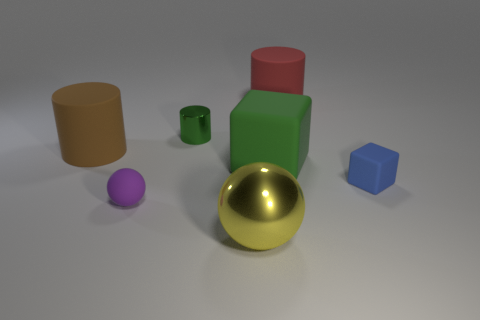What material is the blue thing?
Make the answer very short. Rubber. Is the tiny metallic cylinder the same color as the big rubber block?
Offer a terse response. Yes. What number of rubber cylinders are there?
Offer a very short reply. 2. What is the material of the big object that is in front of the blue cube in front of the brown object?
Provide a short and direct response. Metal. What material is the yellow ball that is the same size as the brown cylinder?
Give a very brief answer. Metal. Do the metallic object in front of the blue rubber thing and the purple rubber object have the same size?
Ensure brevity in your answer.  No. There is a metal object that is behind the yellow metal object; is its shape the same as the blue rubber thing?
Make the answer very short. No. How many objects are small matte objects or large rubber things that are in front of the brown cylinder?
Your response must be concise. 3. Is the number of large brown rubber cylinders less than the number of tiny blue rubber cylinders?
Make the answer very short. No. Is the number of yellow shiny things greater than the number of brown rubber spheres?
Provide a short and direct response. Yes. 